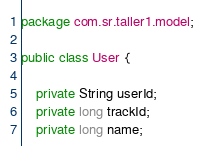Convert code to text. <code><loc_0><loc_0><loc_500><loc_500><_Java_>package com.sr.taller1.model;

public class User {

    private String userId;
    private long trackId;
    private long name;
</code> 